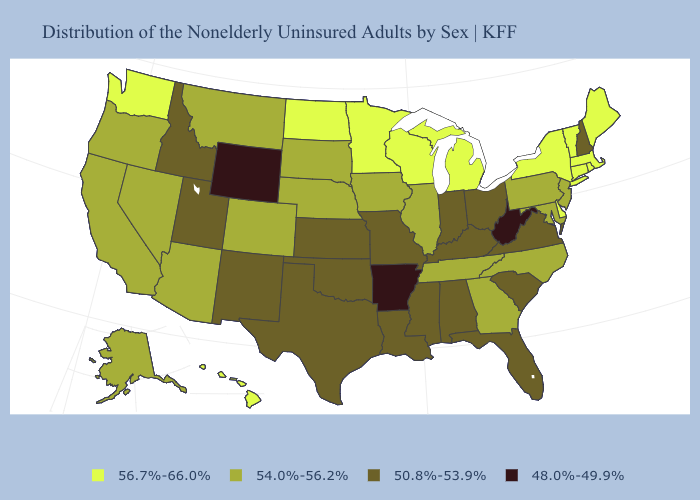What is the value of Wyoming?
Keep it brief. 48.0%-49.9%. Name the states that have a value in the range 56.7%-66.0%?
Concise answer only. Connecticut, Delaware, Hawaii, Maine, Massachusetts, Michigan, Minnesota, New York, North Dakota, Rhode Island, Vermont, Washington, Wisconsin. What is the lowest value in the West?
Be succinct. 48.0%-49.9%. Which states hav the highest value in the West?
Answer briefly. Hawaii, Washington. Among the states that border Illinois , does Iowa have the lowest value?
Concise answer only. No. Does New Jersey have the highest value in the Northeast?
Answer briefly. No. What is the lowest value in the USA?
Give a very brief answer. 48.0%-49.9%. What is the lowest value in the MidWest?
Give a very brief answer. 50.8%-53.9%. What is the highest value in the USA?
Quick response, please. 56.7%-66.0%. Does Vermont have the highest value in the USA?
Give a very brief answer. Yes. What is the value of Oklahoma?
Quick response, please. 50.8%-53.9%. What is the value of Alaska?
Short answer required. 54.0%-56.2%. Name the states that have a value in the range 54.0%-56.2%?
Write a very short answer. Alaska, Arizona, California, Colorado, Georgia, Illinois, Iowa, Maryland, Montana, Nebraska, Nevada, New Jersey, North Carolina, Oregon, Pennsylvania, South Dakota, Tennessee. Name the states that have a value in the range 50.8%-53.9%?
Give a very brief answer. Alabama, Florida, Idaho, Indiana, Kansas, Kentucky, Louisiana, Mississippi, Missouri, New Hampshire, New Mexico, Ohio, Oklahoma, South Carolina, Texas, Utah, Virginia. Name the states that have a value in the range 48.0%-49.9%?
Write a very short answer. Arkansas, West Virginia, Wyoming. 